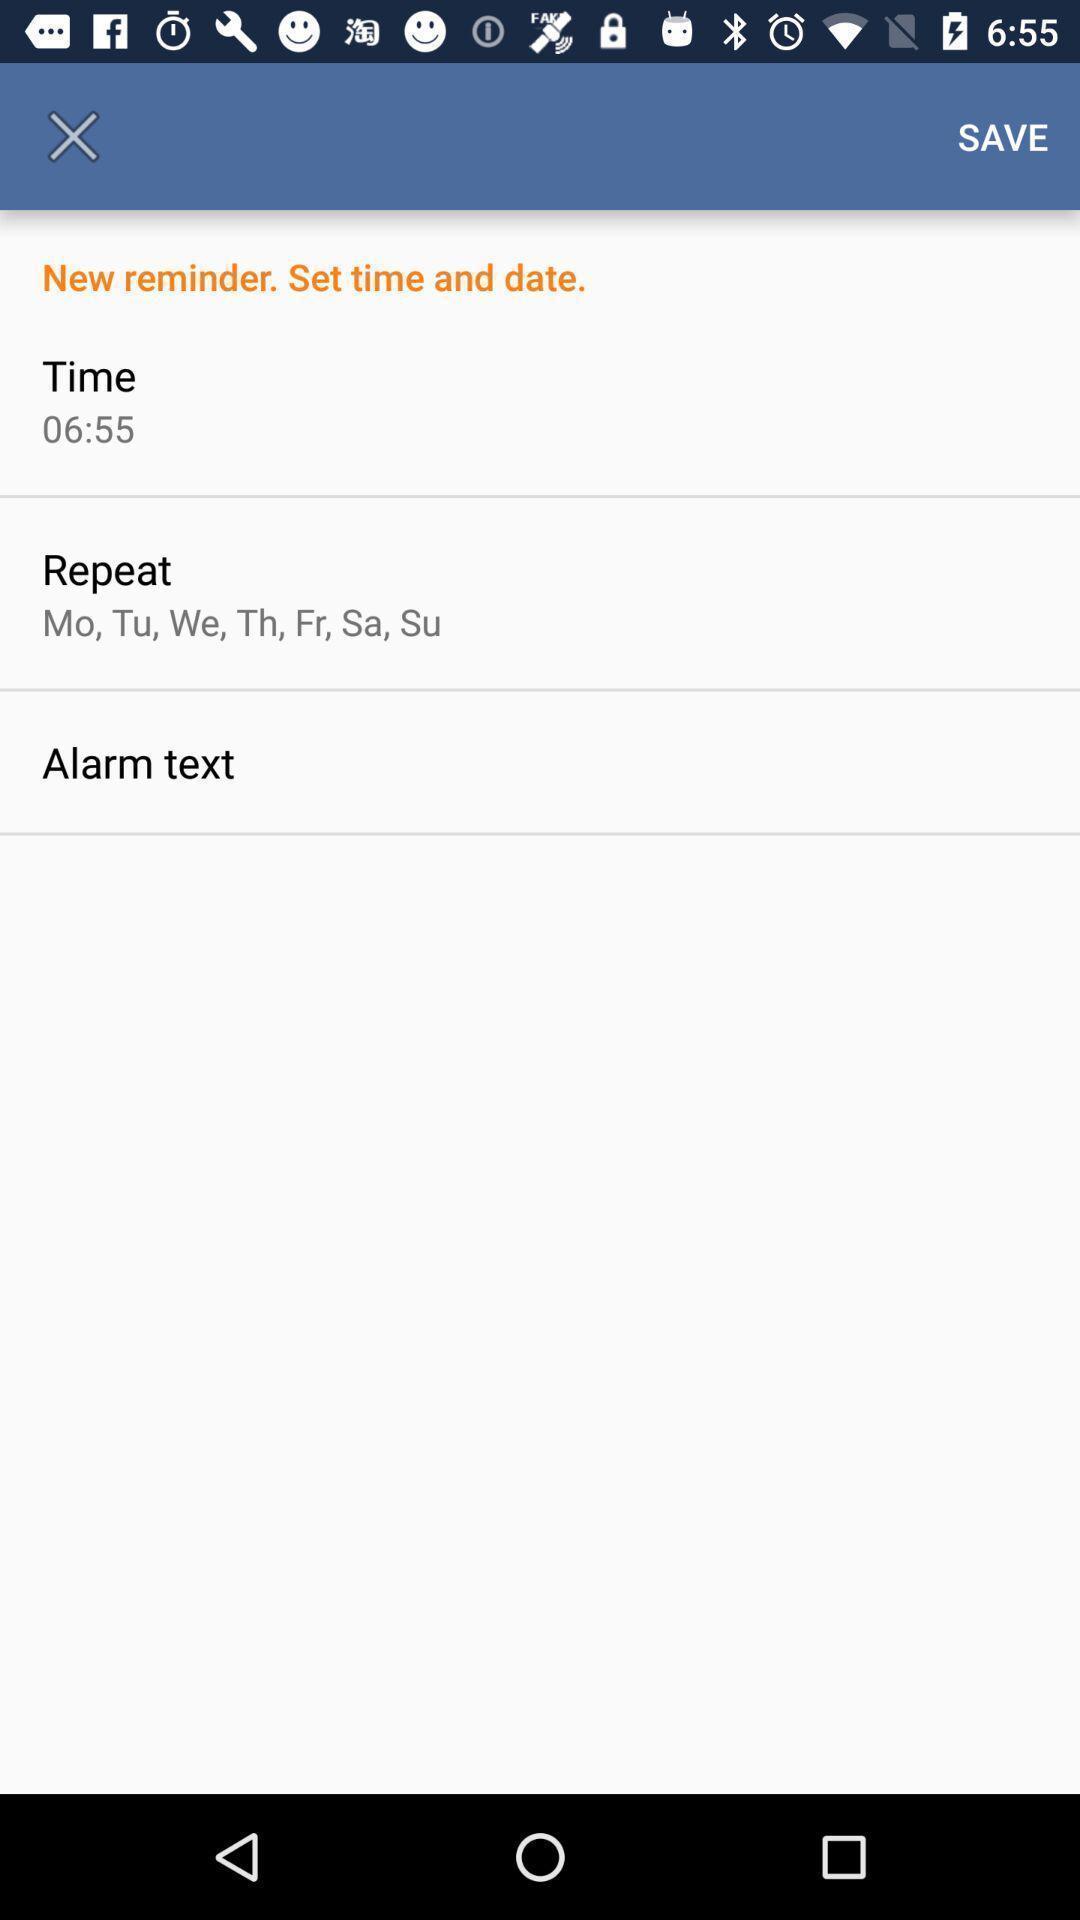Describe this image in words. Screen shows the display of save option. 